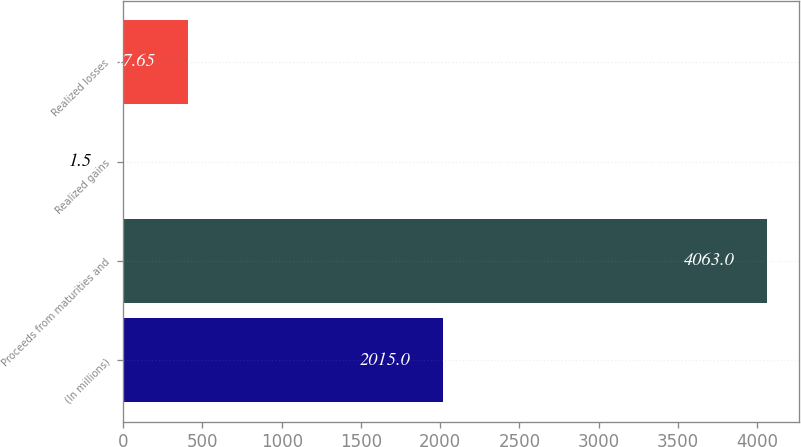Convert chart to OTSL. <chart><loc_0><loc_0><loc_500><loc_500><bar_chart><fcel>(In millions)<fcel>Proceeds from maturities and<fcel>Realized gains<fcel>Realized losses<nl><fcel>2015<fcel>4063<fcel>1.5<fcel>407.65<nl></chart> 